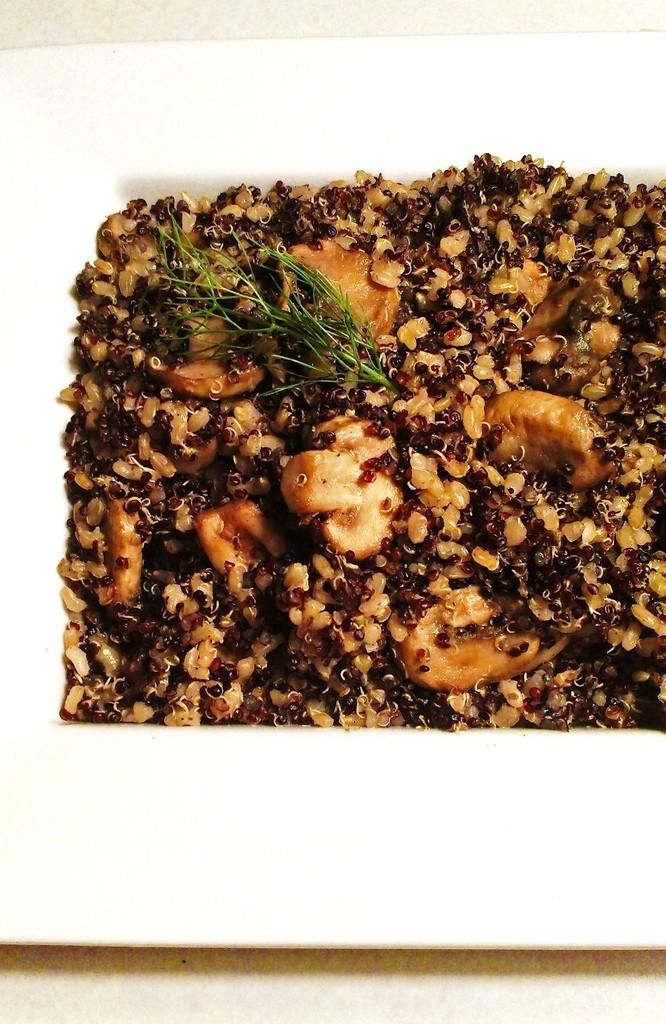What is present on the plate in the image? There are food items on the plate in the image. Can you see a doll playing near the harbor in the image? There is no doll or harbor present in the image; it only features food items on a plate. 